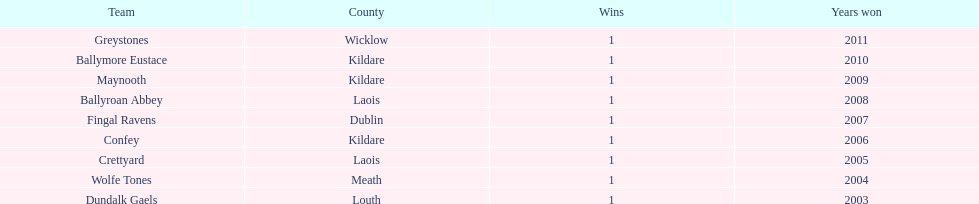What is the count of triumphs for confey? 1. 